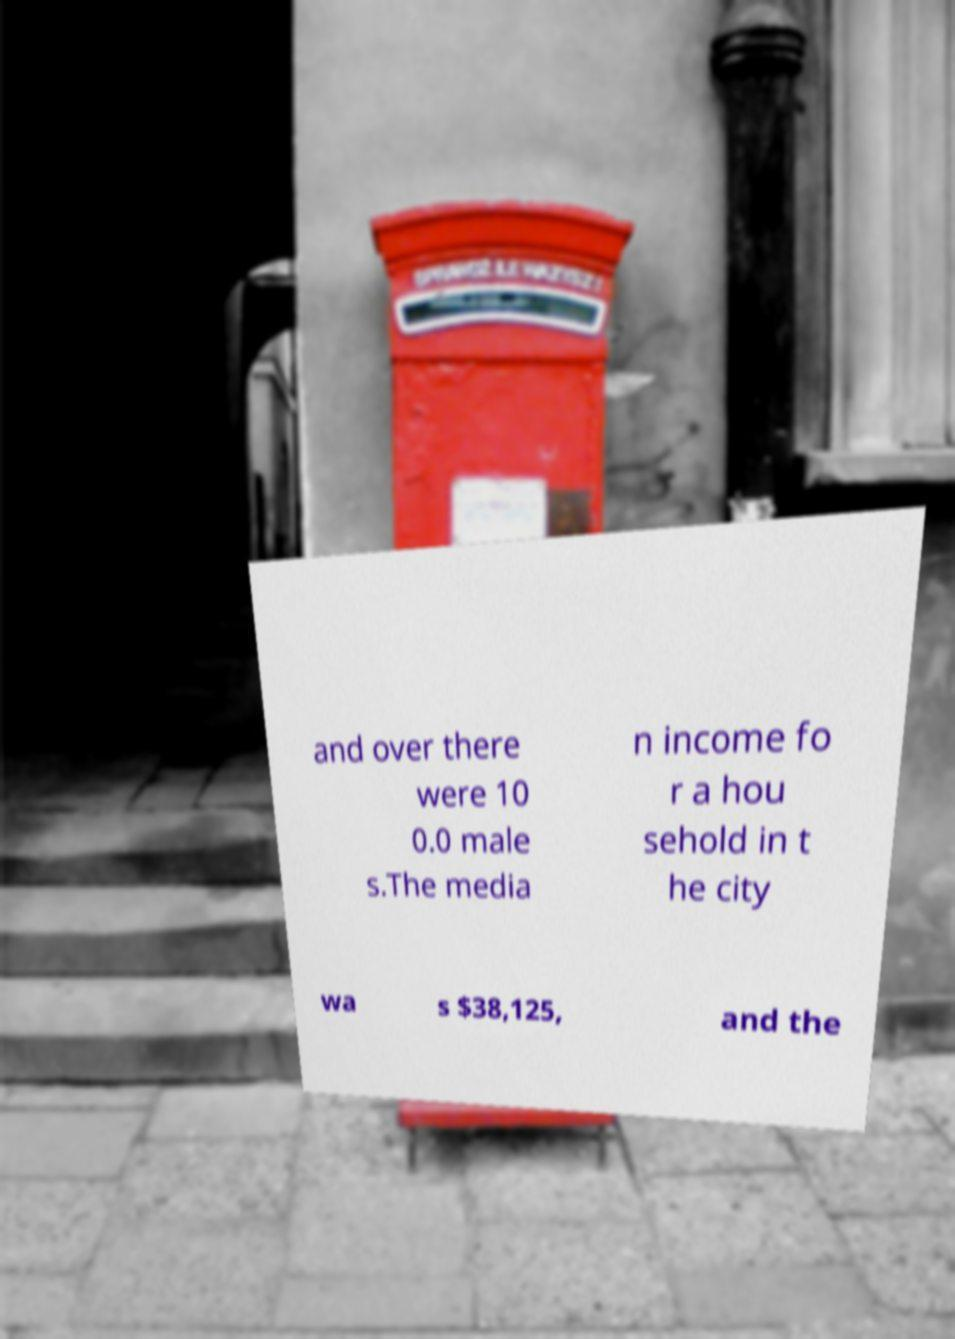I need the written content from this picture converted into text. Can you do that? and over there were 10 0.0 male s.The media n income fo r a hou sehold in t he city wa s $38,125, and the 